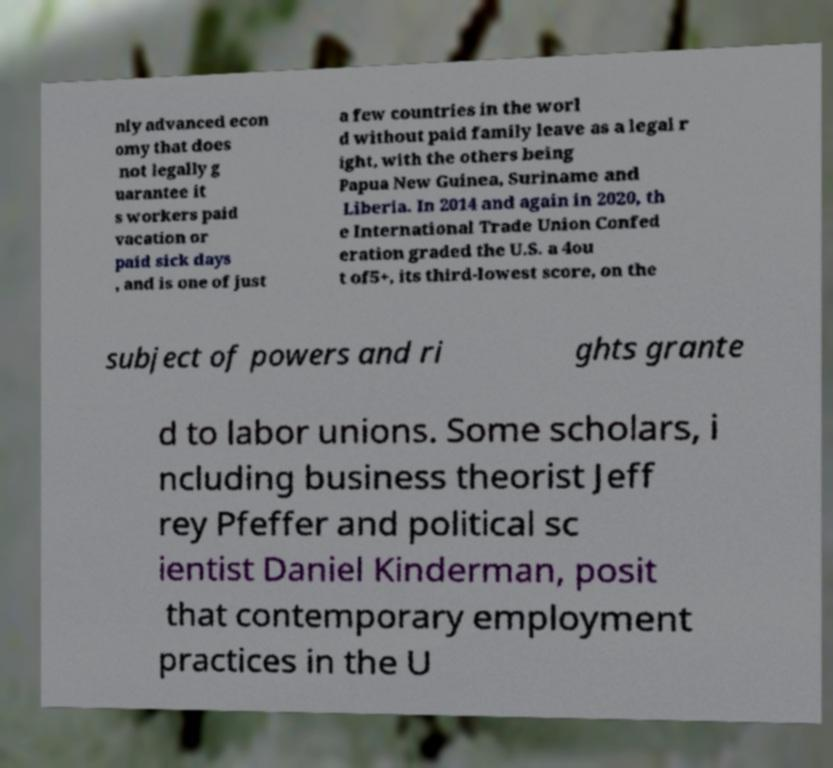There's text embedded in this image that I need extracted. Can you transcribe it verbatim? nly advanced econ omy that does not legally g uarantee it s workers paid vacation or paid sick days , and is one of just a few countries in the worl d without paid family leave as a legal r ight, with the others being Papua New Guinea, Suriname and Liberia. In 2014 and again in 2020, th e International Trade Union Confed eration graded the U.S. a 4ou t of5+, its third-lowest score, on the subject of powers and ri ghts grante d to labor unions. Some scholars, i ncluding business theorist Jeff rey Pfeffer and political sc ientist Daniel Kinderman, posit that contemporary employment practices in the U 